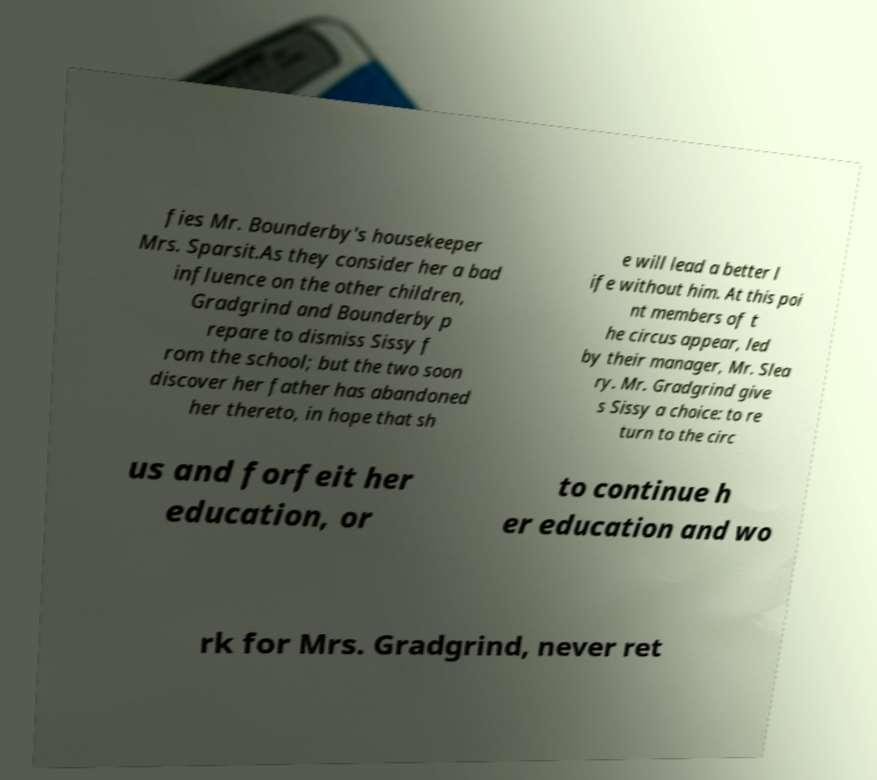Please identify and transcribe the text found in this image. fies Mr. Bounderby's housekeeper Mrs. Sparsit.As they consider her a bad influence on the other children, Gradgrind and Bounderby p repare to dismiss Sissy f rom the school; but the two soon discover her father has abandoned her thereto, in hope that sh e will lead a better l ife without him. At this poi nt members of t he circus appear, led by their manager, Mr. Slea ry. Mr. Gradgrind give s Sissy a choice: to re turn to the circ us and forfeit her education, or to continue h er education and wo rk for Mrs. Gradgrind, never ret 